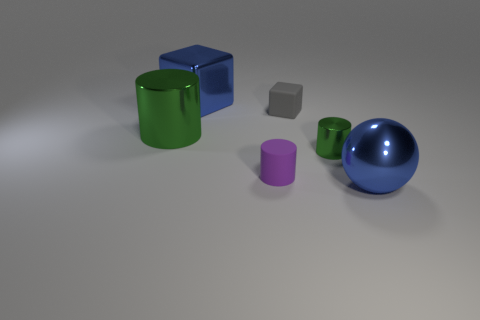Add 4 big metal balls. How many objects exist? 10 Subtract all purple cylinders. How many cylinders are left? 2 Subtract all yellow blocks. How many purple cylinders are left? 1 Subtract all large metallic cylinders. How many cylinders are left? 2 Subtract all blocks. How many objects are left? 4 Subtract 2 blocks. How many blocks are left? 0 Subtract all gray balls. Subtract all red blocks. How many balls are left? 1 Subtract all metal cylinders. Subtract all rubber cylinders. How many objects are left? 3 Add 5 gray matte things. How many gray matte things are left? 6 Add 6 tiny matte cylinders. How many tiny matte cylinders exist? 7 